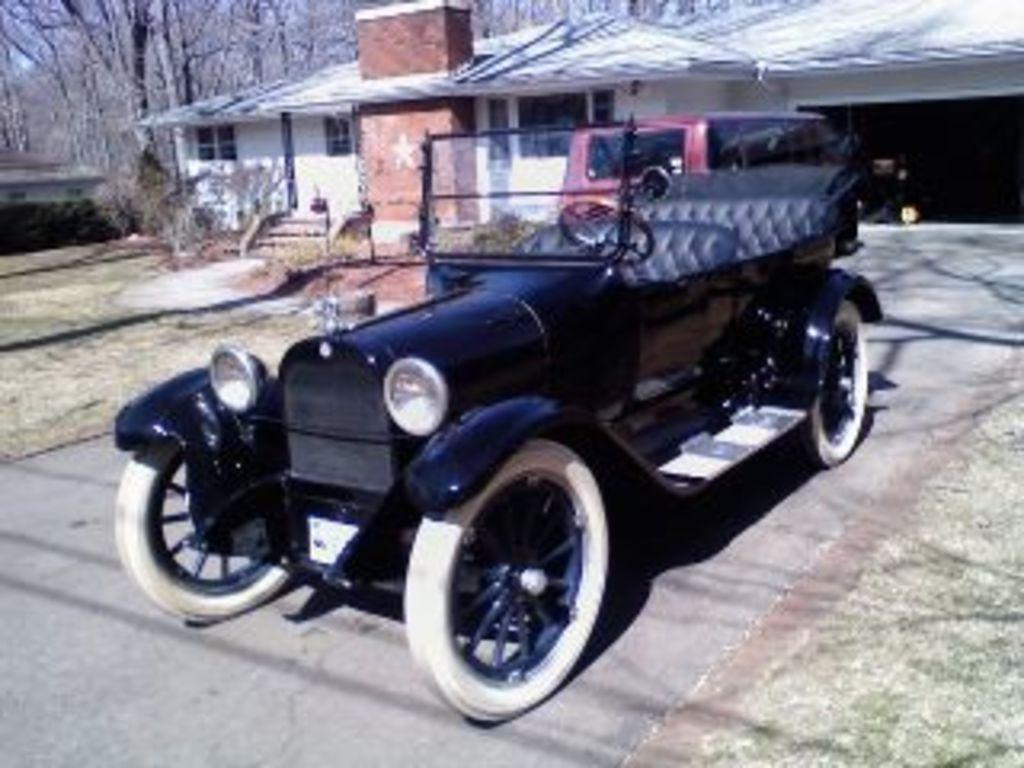What is the main subject in the foreground of the image? There is a vehicle on the road in the foreground of the image. What type of vegetation can be seen in the foreground? Grass is present in the foreground of the image. What structures are visible in the background of the image? There is a house, plants, steps, trees, and other houses in the background of the image. Can you describe the person in the background of the image? There is a person in the background of the image, but no specific details about the person are provided. What can be inferred about the time of day when the image was taken? The image is likely taken during the day, as there is no indication of darkness or artificial lighting. What title is given to the girl in the image? There is no girl present in the image, so there is no title to be given. 